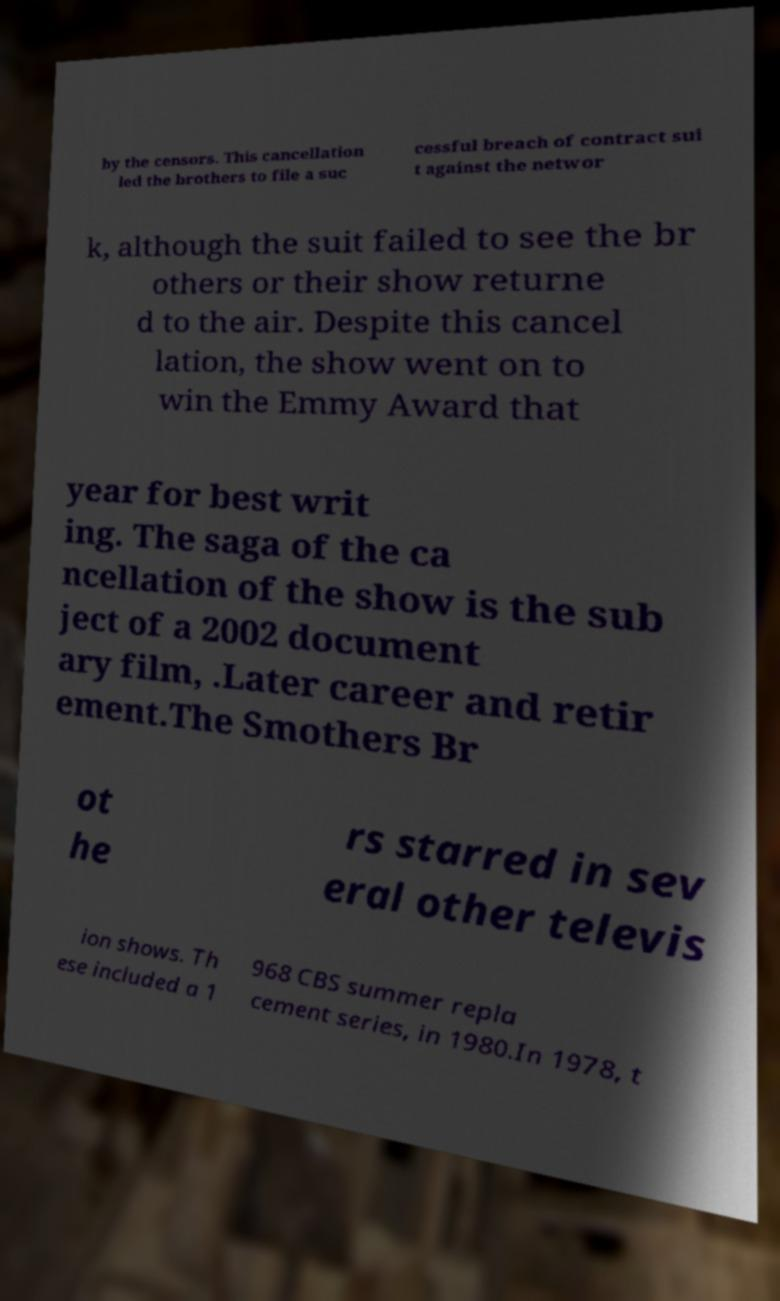Could you assist in decoding the text presented in this image and type it out clearly? by the censors. This cancellation led the brothers to file a suc cessful breach of contract sui t against the networ k, although the suit failed to see the br others or their show returne d to the air. Despite this cancel lation, the show went on to win the Emmy Award that year for best writ ing. The saga of the ca ncellation of the show is the sub ject of a 2002 document ary film, .Later career and retir ement.The Smothers Br ot he rs starred in sev eral other televis ion shows. Th ese included a 1 968 CBS summer repla cement series, in 1980.In 1978, t 